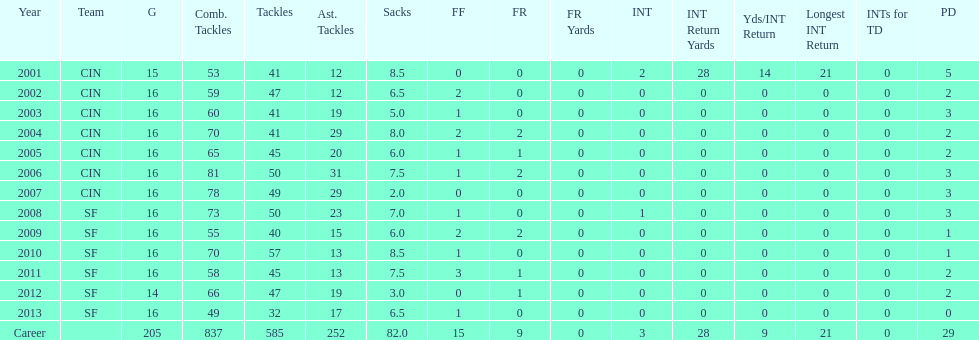What is the average number of tackles this player has had over his career? 45. 